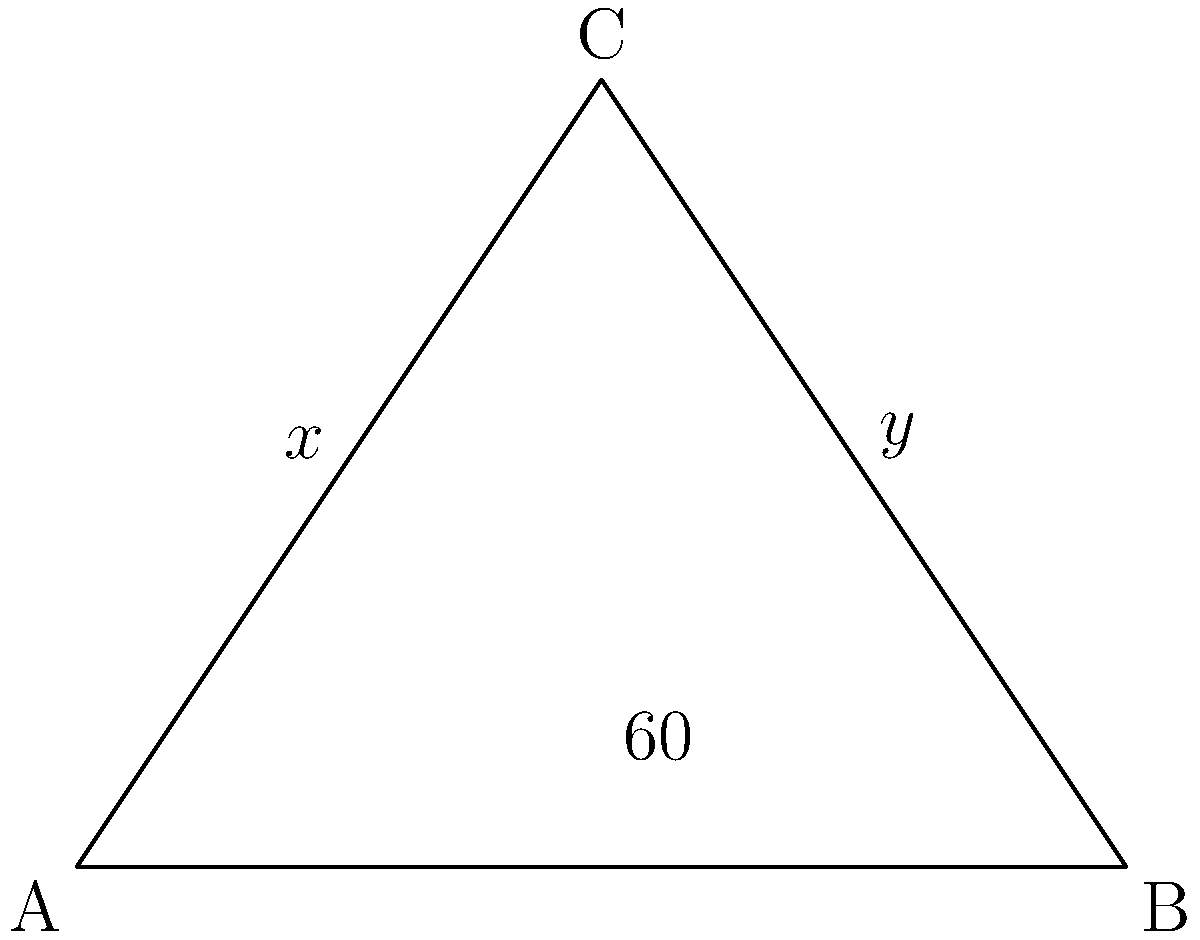In designing a new solar panel array for the International Space Station, you encounter a triangular configuration as shown. If angle BAC is 60°, what is the value of angle ACB (y°)? Let's approach this step-by-step:

1) In any triangle, the sum of all angles is 180°.

2) We are given that angle BAC is 60°.

3) Let's denote the angles:
   - Angle BAC = 60°
   - Angle ABC = x°
   - Angle ACB = y° (this is what we need to find)

4) Using the triangle angle sum theorem:
   $$60° + x° + y° = 180°$$

5) We can see that the triangle is isosceles, as the two angles opposite the equal sides must be equal. Therefore, x° = y°.

6) Let's substitute y for x in our equation:
   $$60° + y° + y° = 180°$$
   $$60° + 2y° = 180°$$

7) Solve for y:
   $$2y° = 120°$$
   $$y° = 60°$$

Therefore, angle ACB (y°) is 60°.
Answer: 60° 